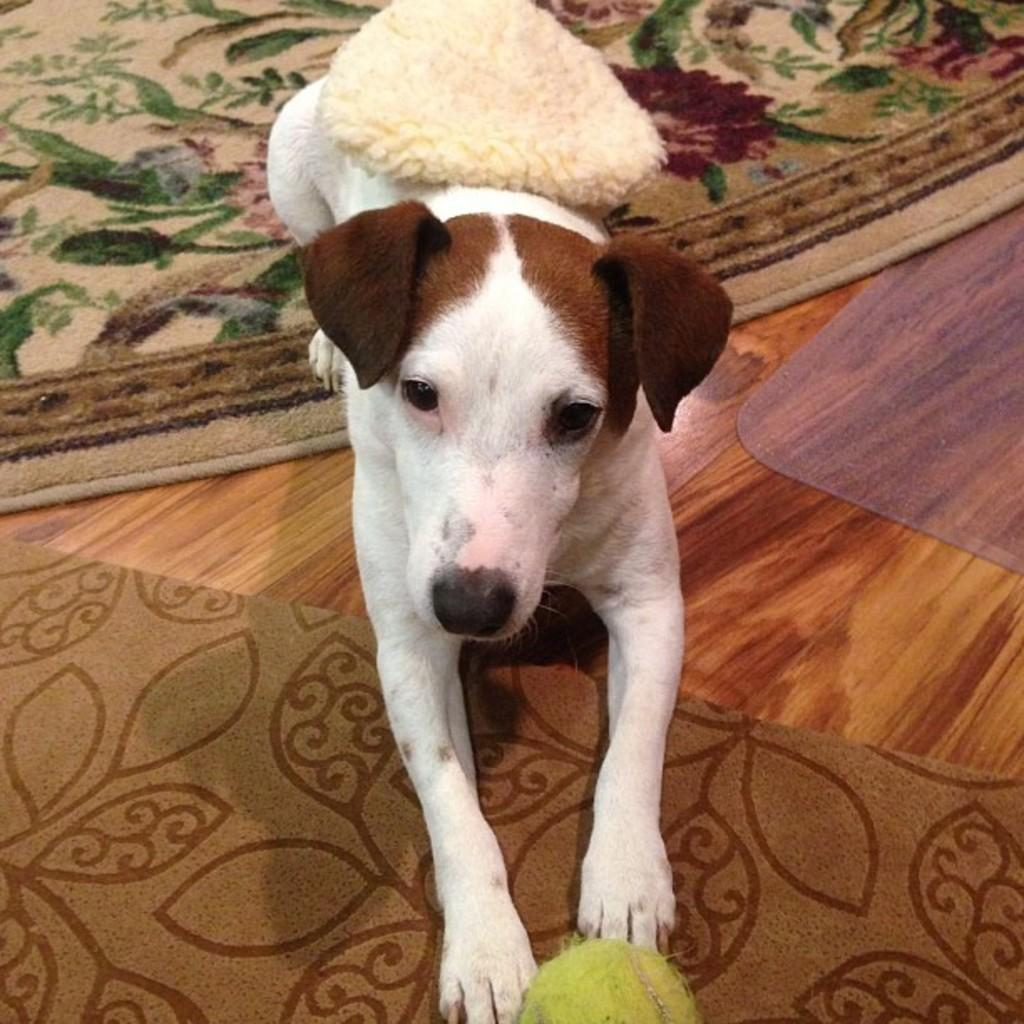What type of animal can be seen in the picture? There is a dog in the picture. What is the dog doing in the image? The dog is laying down. What is present at the bottom of the image? There are mats at the bottom of the image. What type of surface is visible in the image? There is a wooden surface visible in the image. What type of locket is the dog wearing in the image? There is no locket present in the image; the dog is not wearing any accessories. How many knives can be seen in the image? There are no knives present in the image. 